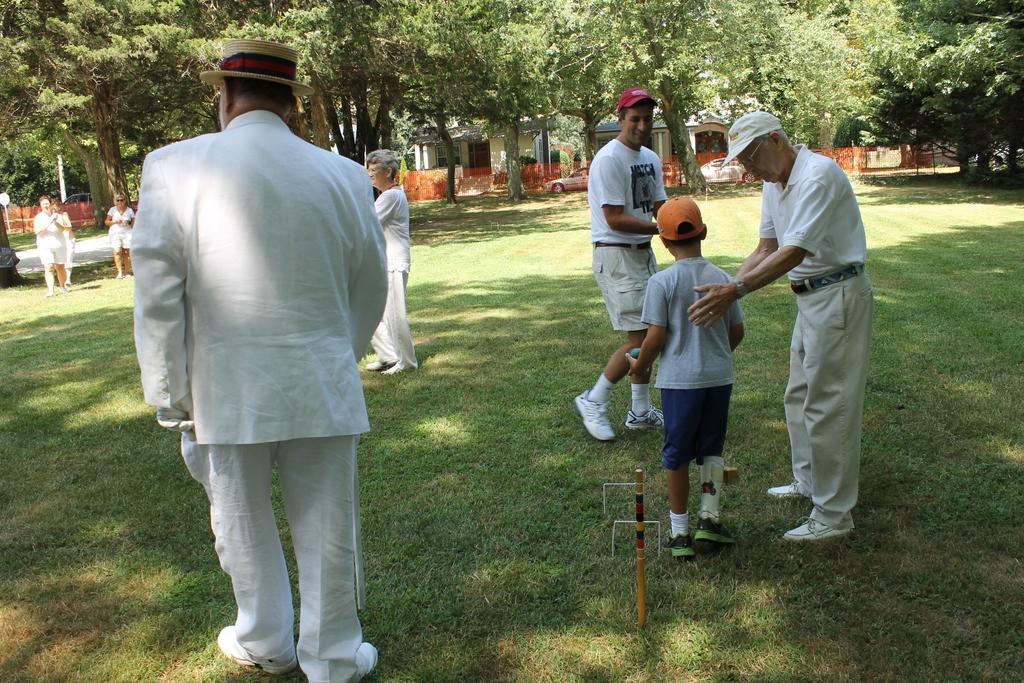Describe this image in one or two sentences. In this image I can see the group of people standing on the grass. These people are wearing the white color dresses and these people are wearing the hats and the caps. In the background there are many trees and the houses. 